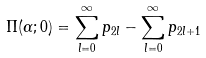Convert formula to latex. <formula><loc_0><loc_0><loc_500><loc_500>\Pi ( \alpha ; 0 ) = \sum _ { l = 0 } ^ { \infty } p _ { 2 l } - \sum _ { l = 0 } ^ { \infty } p _ { 2 l + 1 }</formula> 